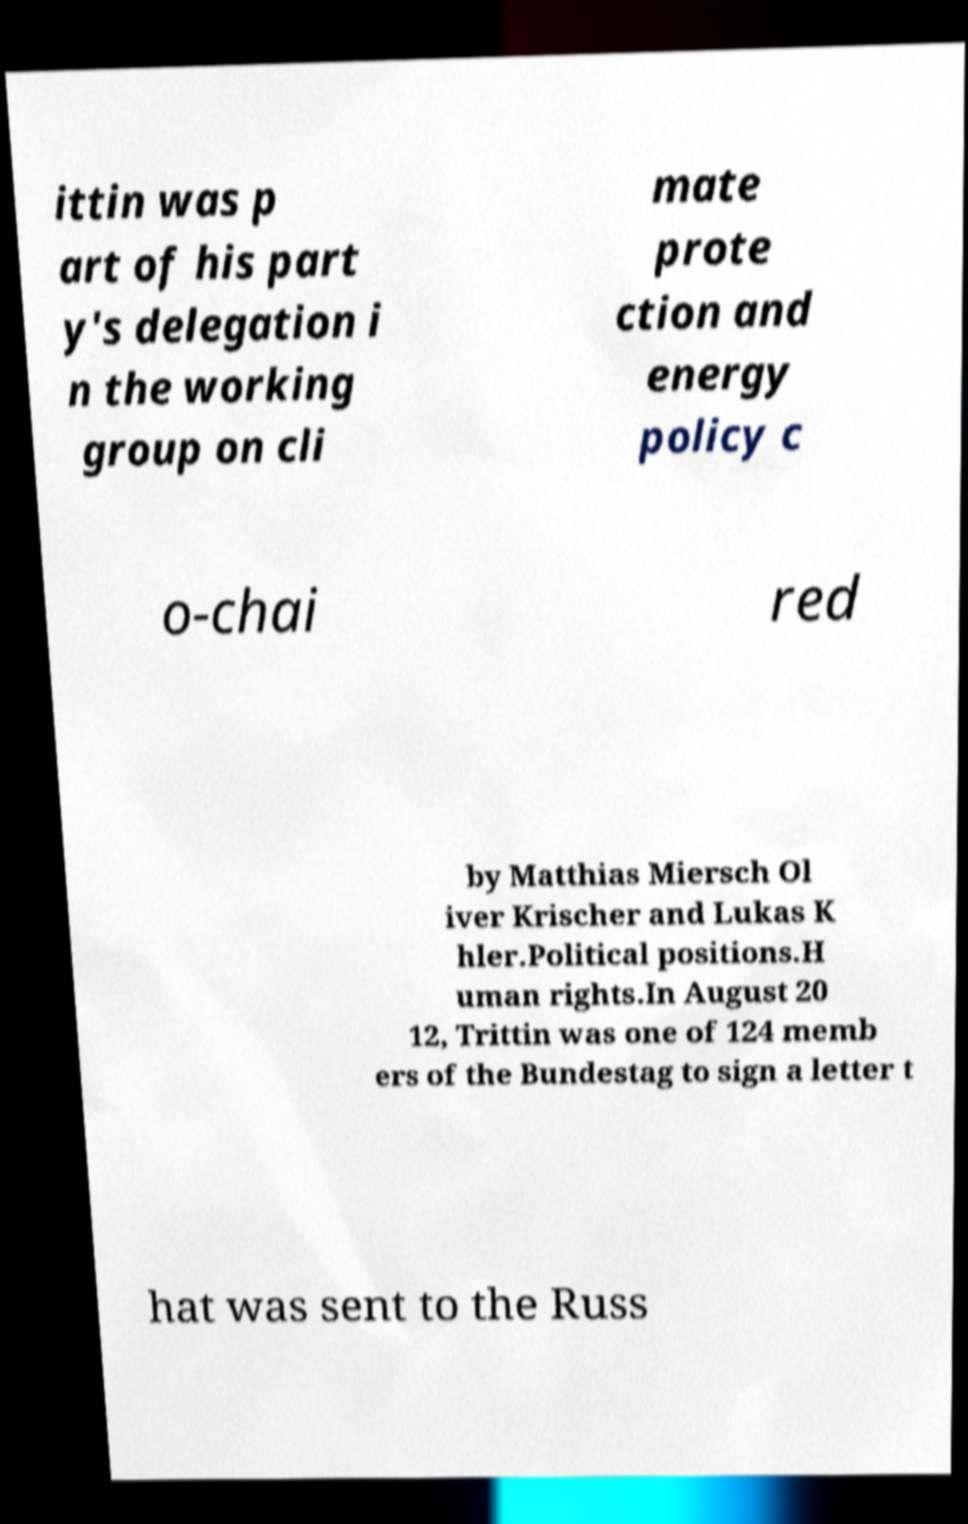Please identify and transcribe the text found in this image. ittin was p art of his part y's delegation i n the working group on cli mate prote ction and energy policy c o-chai red by Matthias Miersch Ol iver Krischer and Lukas K hler.Political positions.H uman rights.In August 20 12, Trittin was one of 124 memb ers of the Bundestag to sign a letter t hat was sent to the Russ 